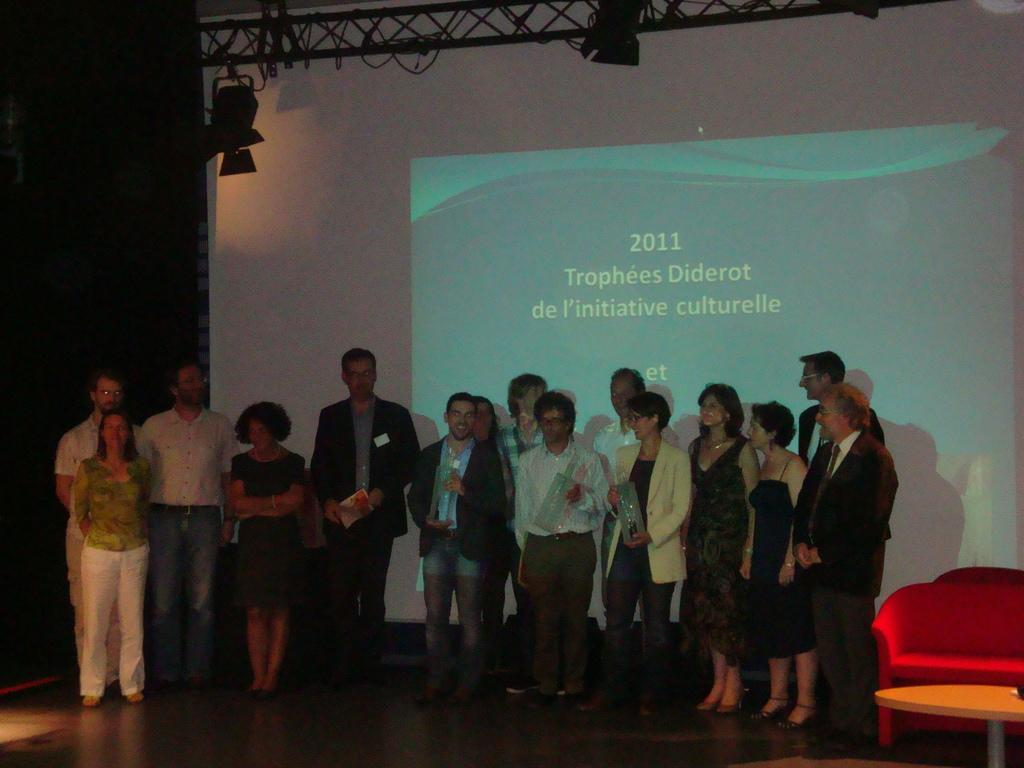What can be seen in the image? There are people standing in the image, along with a chair and a table. Can you describe the background of the image? The background of the image is dark, and there is a screen, rods, and lights visible. How many people are standing in the image? The number of people standing in the image is not specified, but there are clearly multiple individuals present. What type of table is being used to rub the rods in the image? There is no indication in the image that anyone is rubbing the rods, and therefore no table is involved in this activity. 